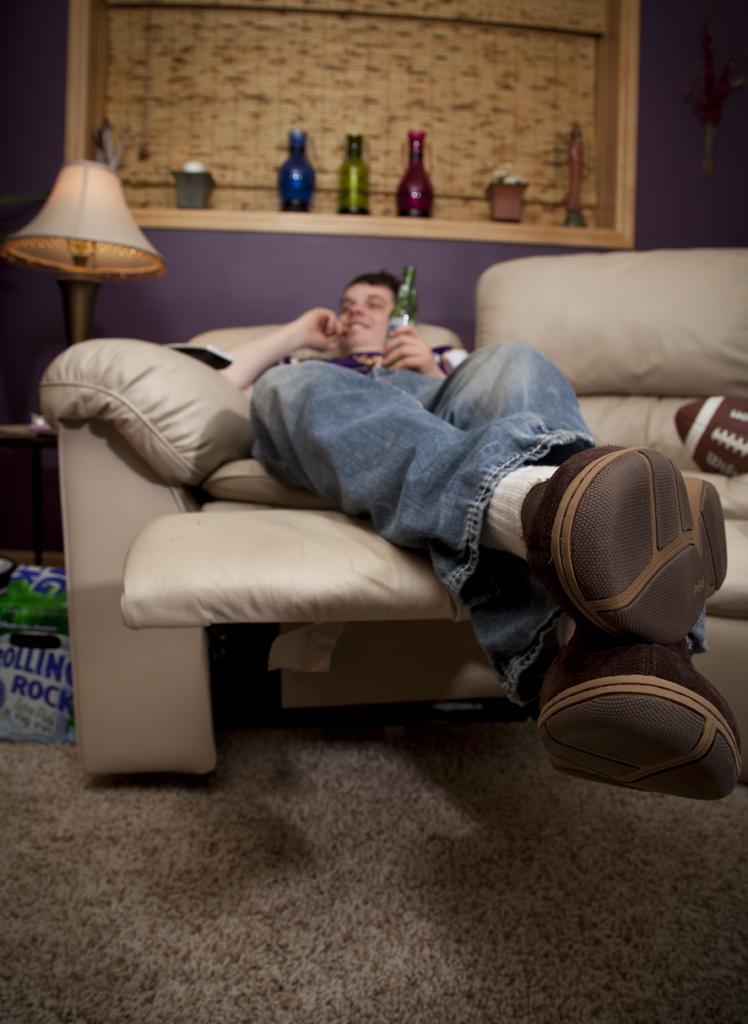Describe this image in one or two sentences. In this image i can see a person lying on the couch. In the background i can see a shelf and few bottles in it and a lamp. 